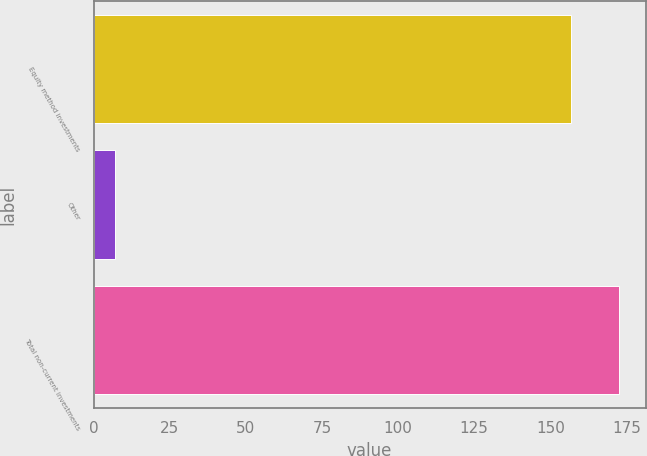Convert chart to OTSL. <chart><loc_0><loc_0><loc_500><loc_500><bar_chart><fcel>Equity method investments<fcel>Other<fcel>Total non-current investments<nl><fcel>156.9<fcel>7<fcel>172.64<nl></chart> 